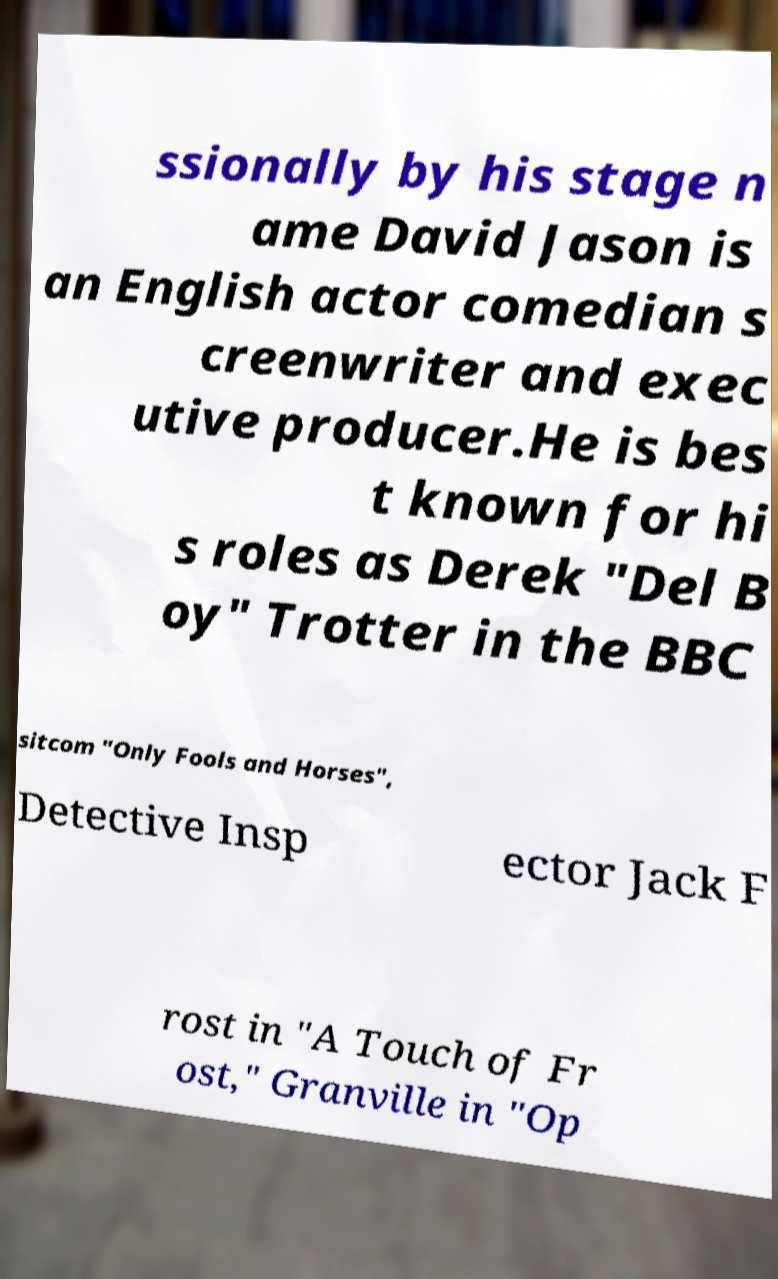For documentation purposes, I need the text within this image transcribed. Could you provide that? ssionally by his stage n ame David Jason is an English actor comedian s creenwriter and exec utive producer.He is bes t known for hi s roles as Derek "Del B oy" Trotter in the BBC sitcom "Only Fools and Horses", Detective Insp ector Jack F rost in "A Touch of Fr ost," Granville in "Op 